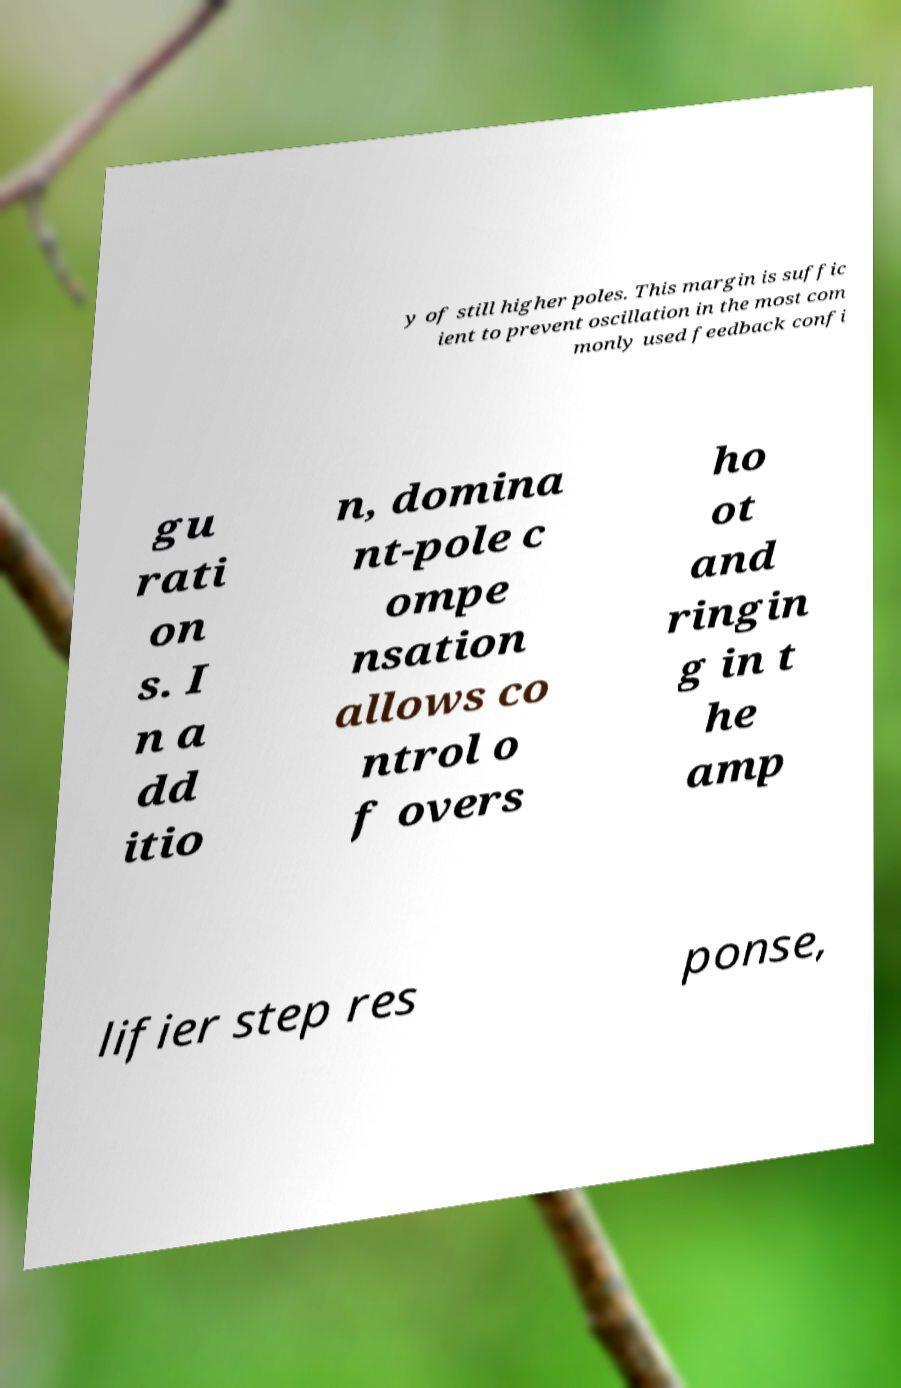I need the written content from this picture converted into text. Can you do that? y of still higher poles. This margin is suffic ient to prevent oscillation in the most com monly used feedback confi gu rati on s. I n a dd itio n, domina nt-pole c ompe nsation allows co ntrol o f overs ho ot and ringin g in t he amp lifier step res ponse, 